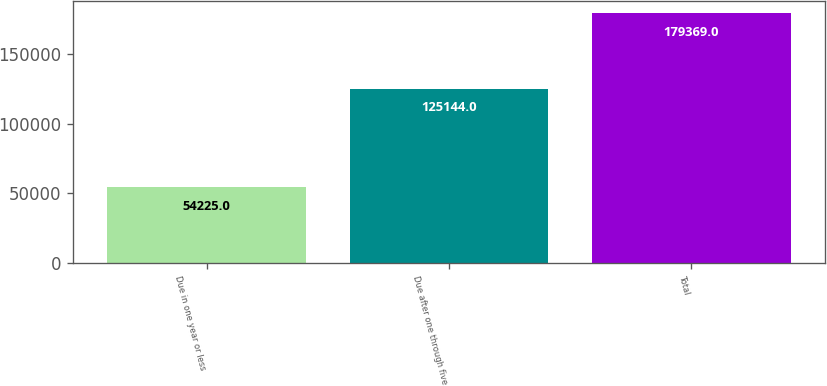<chart> <loc_0><loc_0><loc_500><loc_500><bar_chart><fcel>Due in one year or less<fcel>Due after one through five<fcel>Total<nl><fcel>54225<fcel>125144<fcel>179369<nl></chart> 